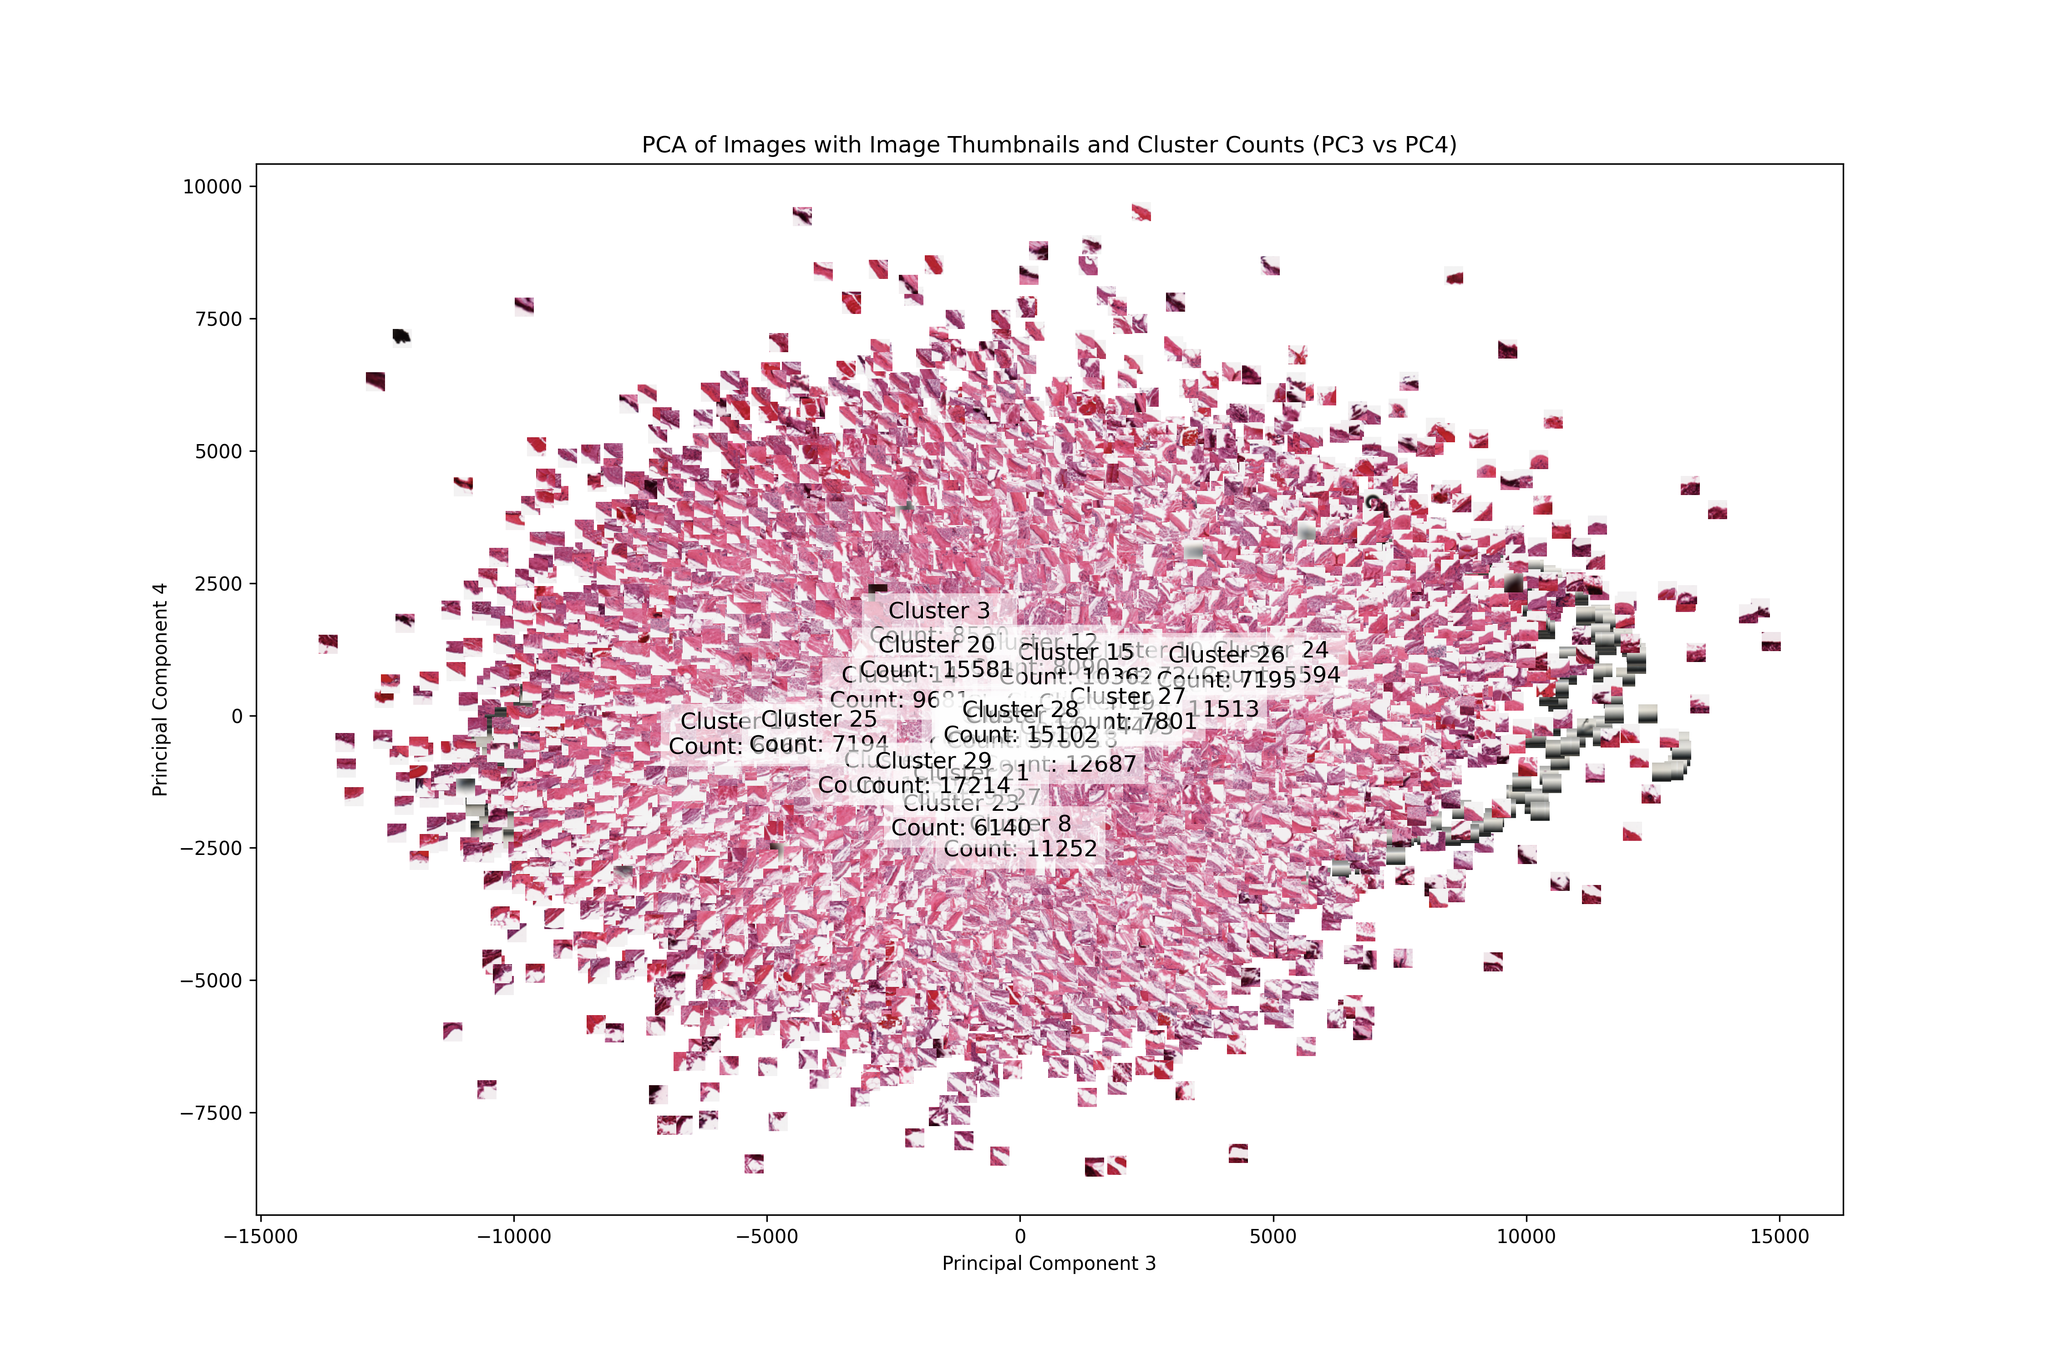In this plot of the PCA to what units does the x and y axis correspond to? The plot shows the result of a Principal Component Analysis (PCA) on a dataset of images. The x-axis corresponds to the first principal component, and the y-axis corresponds to the second principal component. how are the ranges determined? what to they imply? The ranges of the axes in the plot are determined by the data. The data points are plotted on the x-axis and y-axis, and the ranges of the axes are set to include all of the data points. The ranges of the axes are important because they help to show the spread of the data and to identify any outliers.

The ranges of the axes also have implications for the interpretation of the data. For example, if the range of the x-axis is very large, then it may be difficult to see the differences between the data points. Similarly, if the range of the y-axis is very large, then it may be difficult to see the changes in the data over time.

In the case of the plot, the ranges of the axes are set to show the spread of the data and to identify any outliers. The ranges of the axes also help to show the relationships between the data points. For example, the plot shows that there are two clusters of data points. The first cluster is located in the upper left quadrant of the plot, and the second cluster is located in the lower right quadrant of the plot. The ranges of the axes help to show that the two clusters are separated from each other. 